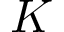<formula> <loc_0><loc_0><loc_500><loc_500>K</formula> 